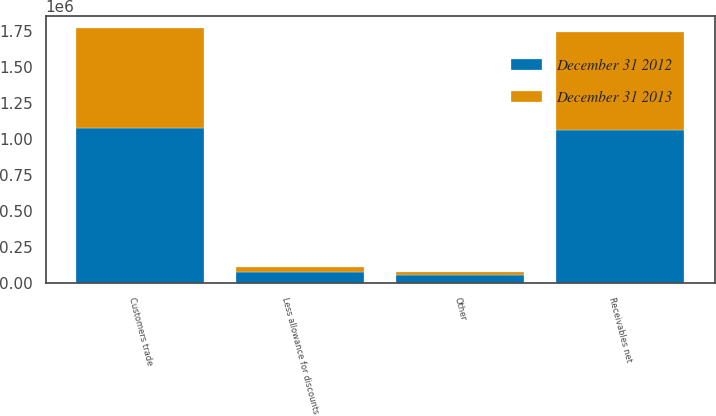Convert chart to OTSL. <chart><loc_0><loc_0><loc_500><loc_500><stacked_bar_chart><ecel><fcel>Customers trade<fcel>Other<fcel>Less allowance for discounts<fcel>Receivables net<nl><fcel>December 31 2012<fcel>1.07682e+06<fcel>55498<fcel>77037<fcel>1.06288e+06<nl><fcel>December 31 2013<fcel>691553<fcel>25793<fcel>37873<fcel>679473<nl></chart> 